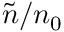<formula> <loc_0><loc_0><loc_500><loc_500>\tilde { n } / n _ { 0 }</formula> 